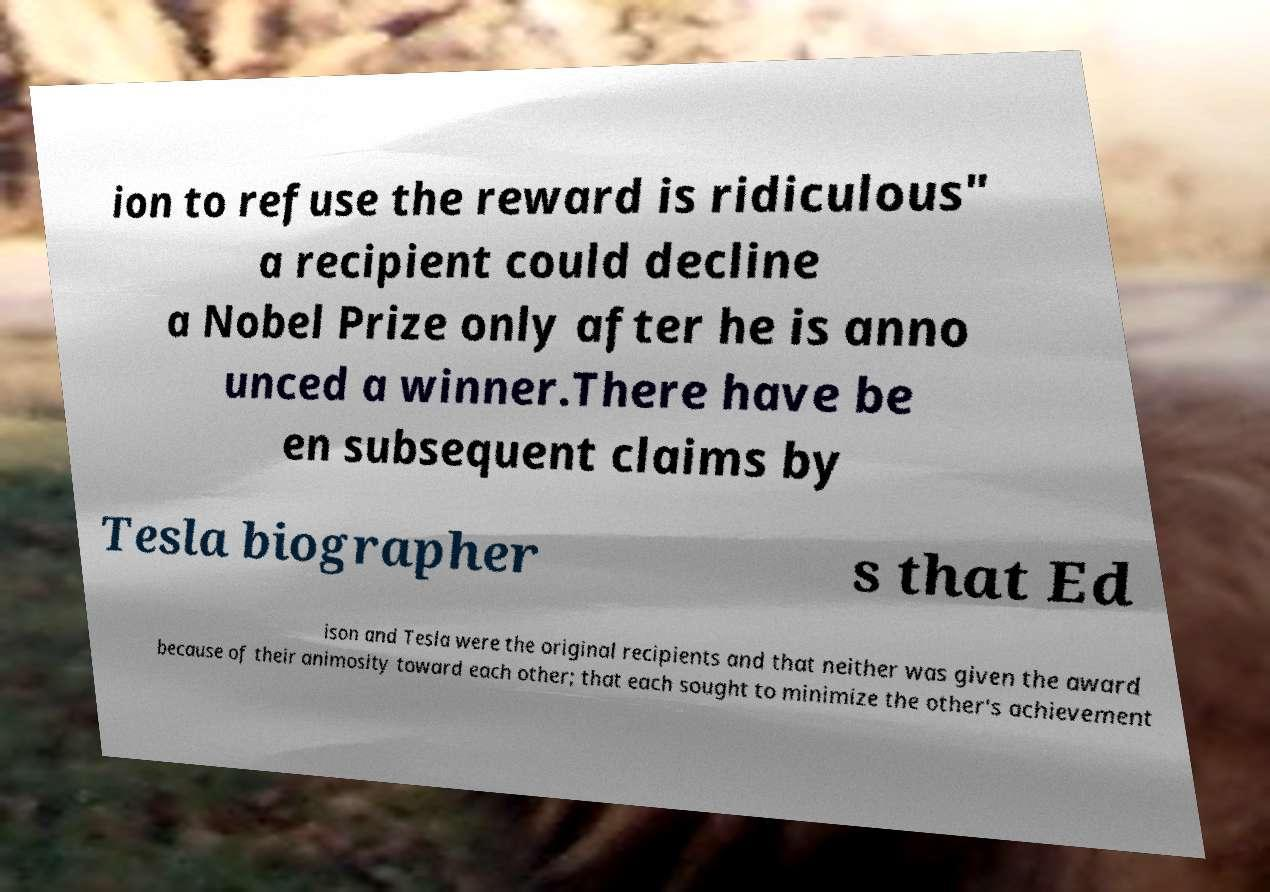Could you assist in decoding the text presented in this image and type it out clearly? ion to refuse the reward is ridiculous" a recipient could decline a Nobel Prize only after he is anno unced a winner.There have be en subsequent claims by Tesla biographer s that Ed ison and Tesla were the original recipients and that neither was given the award because of their animosity toward each other; that each sought to minimize the other's achievement 